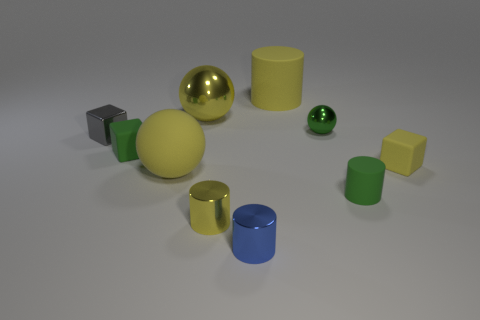Subtract all balls. How many objects are left? 7 Add 7 small green cylinders. How many small green cylinders exist? 8 Subtract 0 cyan cylinders. How many objects are left? 10 Subtract all purple balls. Subtract all tiny yellow rubber blocks. How many objects are left? 9 Add 7 small green shiny things. How many small green shiny things are left? 8 